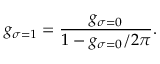<formula> <loc_0><loc_0><loc_500><loc_500>g _ { \sigma = 1 } = \frac { g _ { \sigma = 0 } } { 1 - g _ { \sigma = 0 } / 2 \pi } .</formula> 